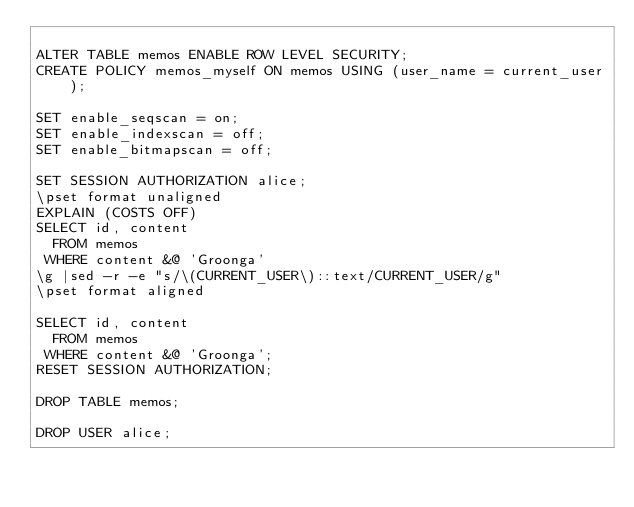<code> <loc_0><loc_0><loc_500><loc_500><_SQL_>
ALTER TABLE memos ENABLE ROW LEVEL SECURITY;
CREATE POLICY memos_myself ON memos USING (user_name = current_user);

SET enable_seqscan = on;
SET enable_indexscan = off;
SET enable_bitmapscan = off;

SET SESSION AUTHORIZATION alice;
\pset format unaligned
EXPLAIN (COSTS OFF)
SELECT id, content
  FROM memos
 WHERE content &@ 'Groonga'
\g |sed -r -e "s/\(CURRENT_USER\)::text/CURRENT_USER/g"
\pset format aligned

SELECT id, content
  FROM memos
 WHERE content &@ 'Groonga';
RESET SESSION AUTHORIZATION;

DROP TABLE memos;

DROP USER alice;
</code> 